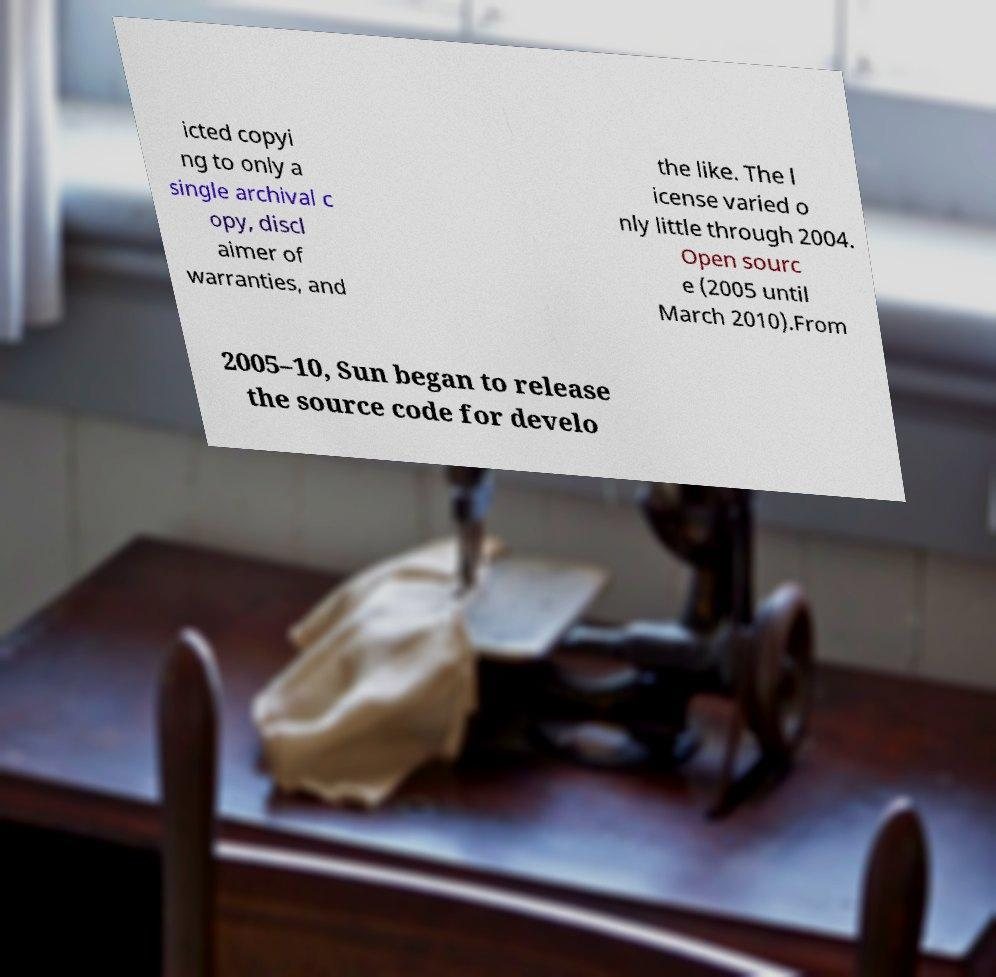What messages or text are displayed in this image? I need them in a readable, typed format. icted copyi ng to only a single archival c opy, discl aimer of warranties, and the like. The l icense varied o nly little through 2004. Open sourc e (2005 until March 2010).From 2005–10, Sun began to release the source code for develo 